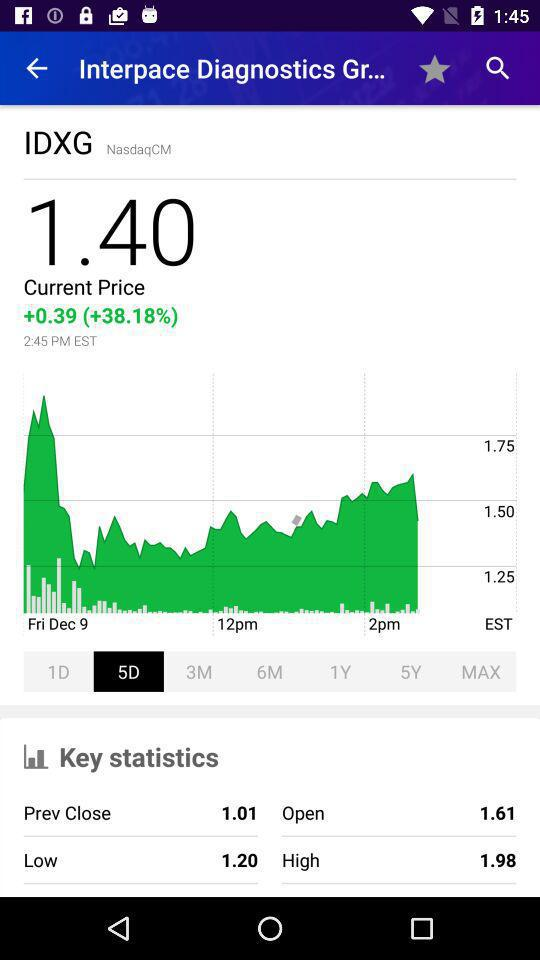How much higher is the current price than the previous close?
Answer the question using a single word or phrase. 0.39 